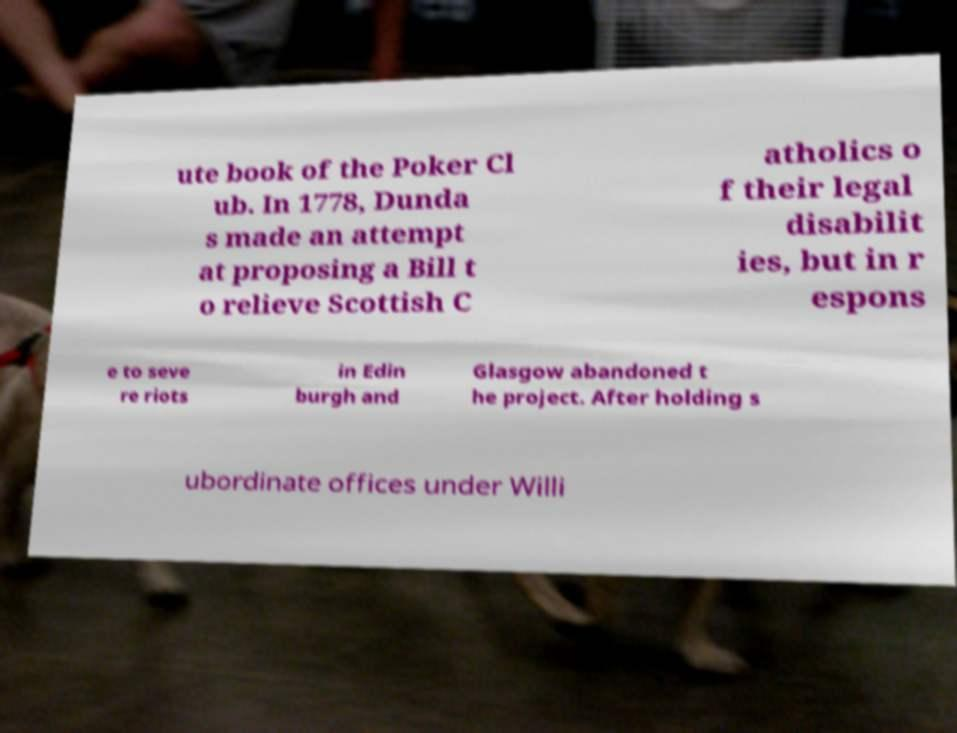For documentation purposes, I need the text within this image transcribed. Could you provide that? ute book of the Poker Cl ub. In 1778, Dunda s made an attempt at proposing a Bill t o relieve Scottish C atholics o f their legal disabilit ies, but in r espons e to seve re riots in Edin burgh and Glasgow abandoned t he project. After holding s ubordinate offices under Willi 